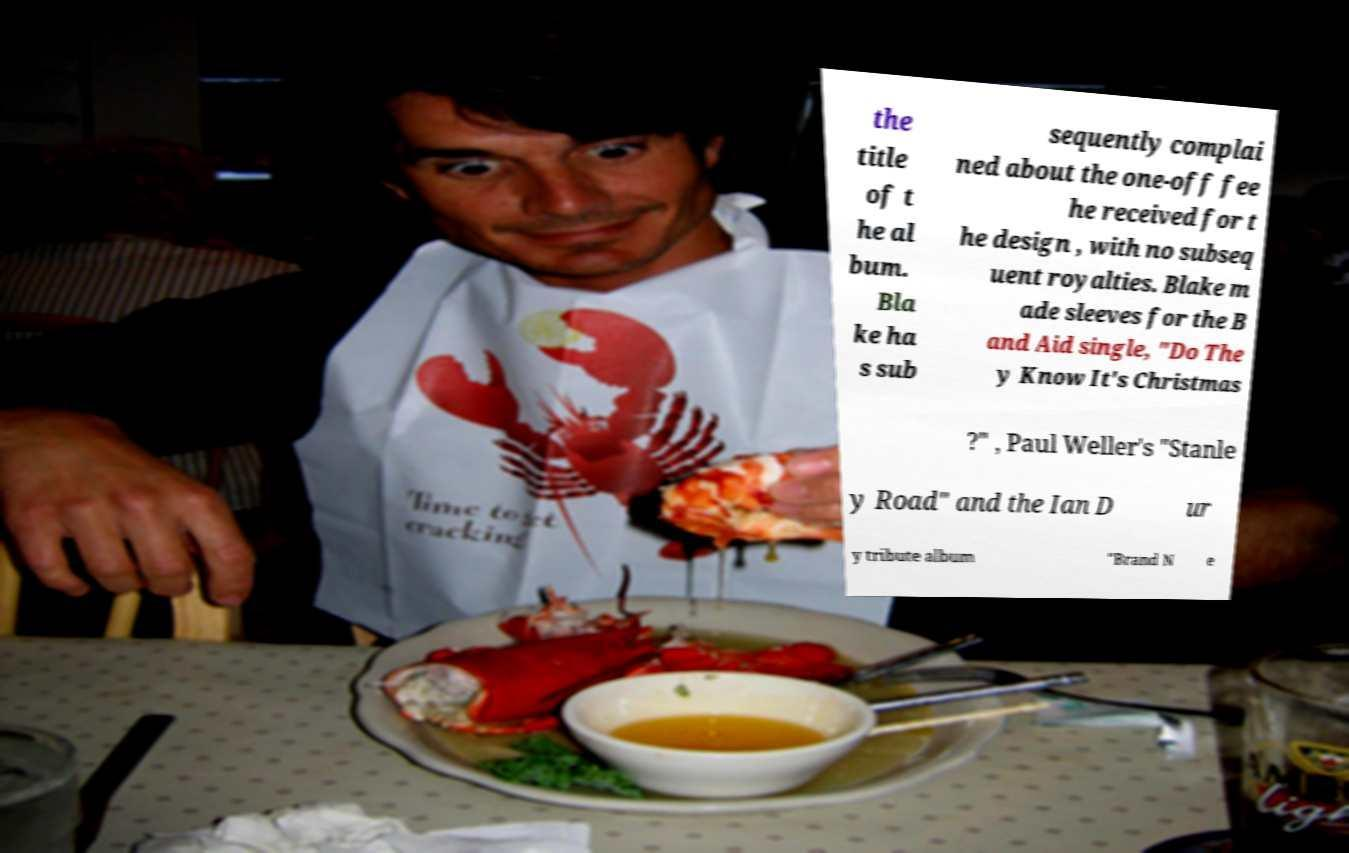There's text embedded in this image that I need extracted. Can you transcribe it verbatim? the title of t he al bum. Bla ke ha s sub sequently complai ned about the one-off fee he received for t he design , with no subseq uent royalties. Blake m ade sleeves for the B and Aid single, "Do The y Know It's Christmas ?" , Paul Weller's "Stanle y Road" and the Ian D ur y tribute album "Brand N e 